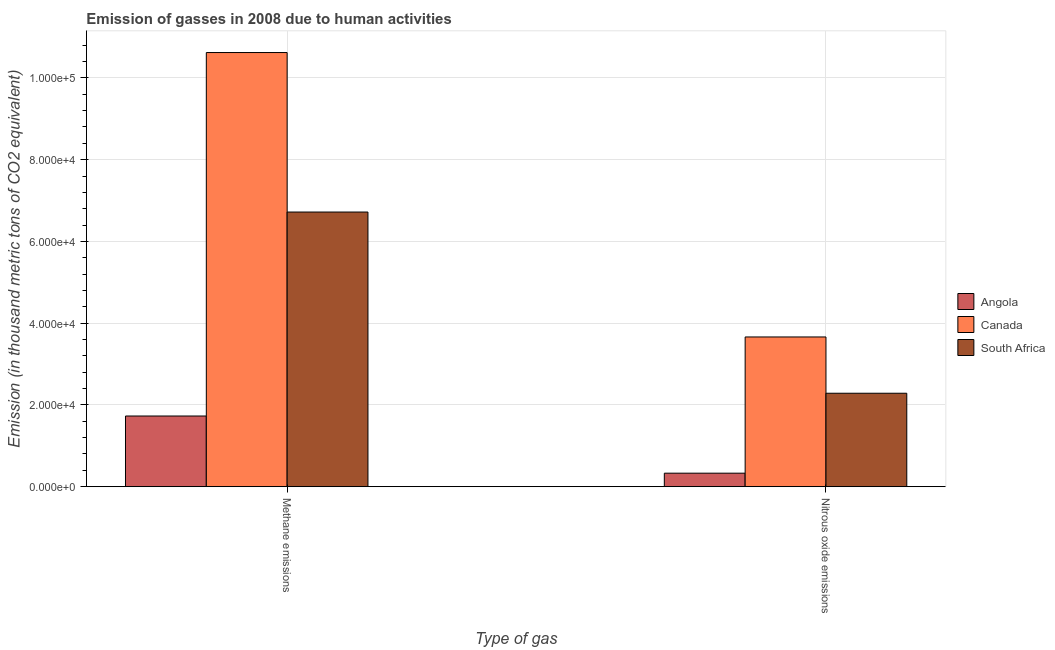Are the number of bars per tick equal to the number of legend labels?
Make the answer very short. Yes. What is the label of the 1st group of bars from the left?
Offer a very short reply. Methane emissions. What is the amount of methane emissions in Angola?
Keep it short and to the point. 1.73e+04. Across all countries, what is the maximum amount of methane emissions?
Your answer should be very brief. 1.06e+05. Across all countries, what is the minimum amount of nitrous oxide emissions?
Give a very brief answer. 3307. In which country was the amount of nitrous oxide emissions maximum?
Offer a terse response. Canada. In which country was the amount of methane emissions minimum?
Make the answer very short. Angola. What is the total amount of methane emissions in the graph?
Keep it short and to the point. 1.91e+05. What is the difference between the amount of methane emissions in Angola and that in South Africa?
Make the answer very short. -4.99e+04. What is the difference between the amount of nitrous oxide emissions in Canada and the amount of methane emissions in Angola?
Your answer should be very brief. 1.93e+04. What is the average amount of methane emissions per country?
Your answer should be very brief. 6.36e+04. What is the difference between the amount of methane emissions and amount of nitrous oxide emissions in Canada?
Provide a short and direct response. 6.96e+04. In how many countries, is the amount of methane emissions greater than 12000 thousand metric tons?
Ensure brevity in your answer.  3. What is the ratio of the amount of nitrous oxide emissions in South Africa to that in Angola?
Offer a terse response. 6.91. What does the 1st bar from the left in Nitrous oxide emissions represents?
Your answer should be very brief. Angola. What does the 1st bar from the right in Nitrous oxide emissions represents?
Your answer should be compact. South Africa. How many bars are there?
Offer a very short reply. 6. How many countries are there in the graph?
Offer a terse response. 3. What is the difference between two consecutive major ticks on the Y-axis?
Offer a very short reply. 2.00e+04. Are the values on the major ticks of Y-axis written in scientific E-notation?
Your answer should be compact. Yes. How are the legend labels stacked?
Provide a short and direct response. Vertical. What is the title of the graph?
Ensure brevity in your answer.  Emission of gasses in 2008 due to human activities. What is the label or title of the X-axis?
Keep it short and to the point. Type of gas. What is the label or title of the Y-axis?
Your response must be concise. Emission (in thousand metric tons of CO2 equivalent). What is the Emission (in thousand metric tons of CO2 equivalent) in Angola in Methane emissions?
Keep it short and to the point. 1.73e+04. What is the Emission (in thousand metric tons of CO2 equivalent) of Canada in Methane emissions?
Make the answer very short. 1.06e+05. What is the Emission (in thousand metric tons of CO2 equivalent) in South Africa in Methane emissions?
Your answer should be compact. 6.72e+04. What is the Emission (in thousand metric tons of CO2 equivalent) in Angola in Nitrous oxide emissions?
Your answer should be compact. 3307. What is the Emission (in thousand metric tons of CO2 equivalent) in Canada in Nitrous oxide emissions?
Your answer should be very brief. 3.66e+04. What is the Emission (in thousand metric tons of CO2 equivalent) of South Africa in Nitrous oxide emissions?
Your response must be concise. 2.29e+04. Across all Type of gas, what is the maximum Emission (in thousand metric tons of CO2 equivalent) in Angola?
Your answer should be compact. 1.73e+04. Across all Type of gas, what is the maximum Emission (in thousand metric tons of CO2 equivalent) in Canada?
Ensure brevity in your answer.  1.06e+05. Across all Type of gas, what is the maximum Emission (in thousand metric tons of CO2 equivalent) of South Africa?
Offer a very short reply. 6.72e+04. Across all Type of gas, what is the minimum Emission (in thousand metric tons of CO2 equivalent) in Angola?
Make the answer very short. 3307. Across all Type of gas, what is the minimum Emission (in thousand metric tons of CO2 equivalent) in Canada?
Provide a succinct answer. 3.66e+04. Across all Type of gas, what is the minimum Emission (in thousand metric tons of CO2 equivalent) of South Africa?
Your answer should be very brief. 2.29e+04. What is the total Emission (in thousand metric tons of CO2 equivalent) of Angola in the graph?
Provide a short and direct response. 2.06e+04. What is the total Emission (in thousand metric tons of CO2 equivalent) in Canada in the graph?
Provide a short and direct response. 1.43e+05. What is the total Emission (in thousand metric tons of CO2 equivalent) in South Africa in the graph?
Provide a succinct answer. 9.00e+04. What is the difference between the Emission (in thousand metric tons of CO2 equivalent) in Angola in Methane emissions and that in Nitrous oxide emissions?
Offer a very short reply. 1.40e+04. What is the difference between the Emission (in thousand metric tons of CO2 equivalent) in Canada in Methane emissions and that in Nitrous oxide emissions?
Provide a short and direct response. 6.96e+04. What is the difference between the Emission (in thousand metric tons of CO2 equivalent) of South Africa in Methane emissions and that in Nitrous oxide emissions?
Make the answer very short. 4.43e+04. What is the difference between the Emission (in thousand metric tons of CO2 equivalent) of Angola in Methane emissions and the Emission (in thousand metric tons of CO2 equivalent) of Canada in Nitrous oxide emissions?
Make the answer very short. -1.93e+04. What is the difference between the Emission (in thousand metric tons of CO2 equivalent) of Angola in Methane emissions and the Emission (in thousand metric tons of CO2 equivalent) of South Africa in Nitrous oxide emissions?
Ensure brevity in your answer.  -5567.1. What is the difference between the Emission (in thousand metric tons of CO2 equivalent) in Canada in Methane emissions and the Emission (in thousand metric tons of CO2 equivalent) in South Africa in Nitrous oxide emissions?
Ensure brevity in your answer.  8.33e+04. What is the average Emission (in thousand metric tons of CO2 equivalent) in Angola per Type of gas?
Your response must be concise. 1.03e+04. What is the average Emission (in thousand metric tons of CO2 equivalent) in Canada per Type of gas?
Your answer should be compact. 7.14e+04. What is the average Emission (in thousand metric tons of CO2 equivalent) of South Africa per Type of gas?
Ensure brevity in your answer.  4.50e+04. What is the difference between the Emission (in thousand metric tons of CO2 equivalent) in Angola and Emission (in thousand metric tons of CO2 equivalent) in Canada in Methane emissions?
Provide a short and direct response. -8.89e+04. What is the difference between the Emission (in thousand metric tons of CO2 equivalent) of Angola and Emission (in thousand metric tons of CO2 equivalent) of South Africa in Methane emissions?
Offer a very short reply. -4.99e+04. What is the difference between the Emission (in thousand metric tons of CO2 equivalent) of Canada and Emission (in thousand metric tons of CO2 equivalent) of South Africa in Methane emissions?
Give a very brief answer. 3.90e+04. What is the difference between the Emission (in thousand metric tons of CO2 equivalent) in Angola and Emission (in thousand metric tons of CO2 equivalent) in Canada in Nitrous oxide emissions?
Your answer should be compact. -3.33e+04. What is the difference between the Emission (in thousand metric tons of CO2 equivalent) of Angola and Emission (in thousand metric tons of CO2 equivalent) of South Africa in Nitrous oxide emissions?
Give a very brief answer. -1.96e+04. What is the difference between the Emission (in thousand metric tons of CO2 equivalent) in Canada and Emission (in thousand metric tons of CO2 equivalent) in South Africa in Nitrous oxide emissions?
Offer a terse response. 1.38e+04. What is the ratio of the Emission (in thousand metric tons of CO2 equivalent) in Angola in Methane emissions to that in Nitrous oxide emissions?
Your answer should be very brief. 5.23. What is the ratio of the Emission (in thousand metric tons of CO2 equivalent) of Canada in Methane emissions to that in Nitrous oxide emissions?
Give a very brief answer. 2.9. What is the ratio of the Emission (in thousand metric tons of CO2 equivalent) in South Africa in Methane emissions to that in Nitrous oxide emissions?
Your answer should be compact. 2.94. What is the difference between the highest and the second highest Emission (in thousand metric tons of CO2 equivalent) of Angola?
Provide a short and direct response. 1.40e+04. What is the difference between the highest and the second highest Emission (in thousand metric tons of CO2 equivalent) in Canada?
Keep it short and to the point. 6.96e+04. What is the difference between the highest and the second highest Emission (in thousand metric tons of CO2 equivalent) of South Africa?
Offer a very short reply. 4.43e+04. What is the difference between the highest and the lowest Emission (in thousand metric tons of CO2 equivalent) in Angola?
Provide a short and direct response. 1.40e+04. What is the difference between the highest and the lowest Emission (in thousand metric tons of CO2 equivalent) of Canada?
Keep it short and to the point. 6.96e+04. What is the difference between the highest and the lowest Emission (in thousand metric tons of CO2 equivalent) of South Africa?
Provide a short and direct response. 4.43e+04. 